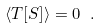<formula> <loc_0><loc_0><loc_500><loc_500>\langle T [ S ] \rangle = 0 \ .</formula> 